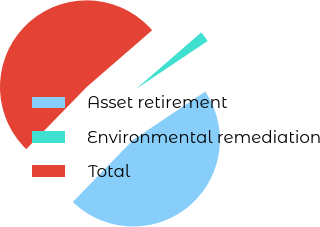Convert chart. <chart><loc_0><loc_0><loc_500><loc_500><pie_chart><fcel>Asset retirement<fcel>Environmental remediation<fcel>Total<nl><fcel>46.68%<fcel>1.97%<fcel>51.35%<nl></chart> 